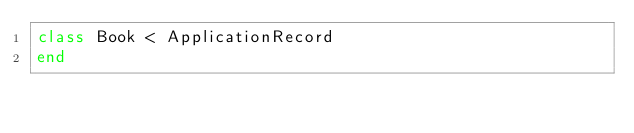<code> <loc_0><loc_0><loc_500><loc_500><_Ruby_>class Book < ApplicationRecord
end
</code> 